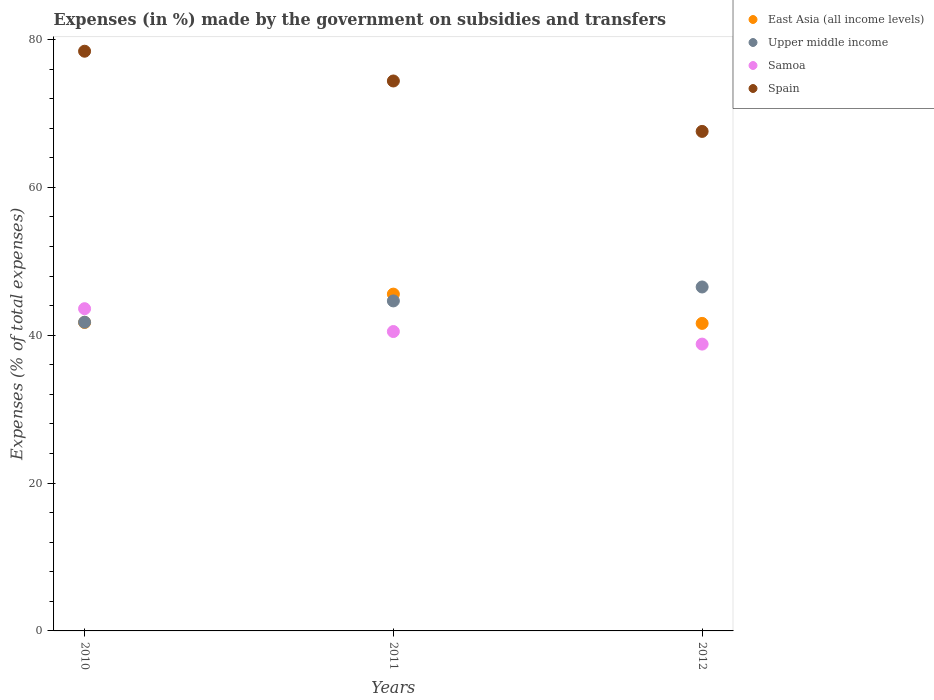How many different coloured dotlines are there?
Offer a terse response. 4. What is the percentage of expenses made by the government on subsidies and transfers in East Asia (all income levels) in 2010?
Provide a succinct answer. 41.72. Across all years, what is the maximum percentage of expenses made by the government on subsidies and transfers in Spain?
Give a very brief answer. 78.42. Across all years, what is the minimum percentage of expenses made by the government on subsidies and transfers in Samoa?
Provide a short and direct response. 38.8. What is the total percentage of expenses made by the government on subsidies and transfers in Samoa in the graph?
Your response must be concise. 122.89. What is the difference between the percentage of expenses made by the government on subsidies and transfers in Spain in 2010 and that in 2011?
Keep it short and to the point. 4.03. What is the difference between the percentage of expenses made by the government on subsidies and transfers in East Asia (all income levels) in 2011 and the percentage of expenses made by the government on subsidies and transfers in Upper middle income in 2012?
Provide a short and direct response. -0.97. What is the average percentage of expenses made by the government on subsidies and transfers in East Asia (all income levels) per year?
Your answer should be compact. 42.96. In the year 2010, what is the difference between the percentage of expenses made by the government on subsidies and transfers in Spain and percentage of expenses made by the government on subsidies and transfers in Upper middle income?
Offer a very short reply. 36.65. In how many years, is the percentage of expenses made by the government on subsidies and transfers in Samoa greater than 16 %?
Your response must be concise. 3. What is the ratio of the percentage of expenses made by the government on subsidies and transfers in Upper middle income in 2010 to that in 2011?
Ensure brevity in your answer.  0.94. Is the percentage of expenses made by the government on subsidies and transfers in Samoa in 2010 less than that in 2011?
Give a very brief answer. No. What is the difference between the highest and the second highest percentage of expenses made by the government on subsidies and transfers in Spain?
Your response must be concise. 4.03. What is the difference between the highest and the lowest percentage of expenses made by the government on subsidies and transfers in Upper middle income?
Give a very brief answer. 4.76. In how many years, is the percentage of expenses made by the government on subsidies and transfers in Samoa greater than the average percentage of expenses made by the government on subsidies and transfers in Samoa taken over all years?
Your answer should be very brief. 1. Is the sum of the percentage of expenses made by the government on subsidies and transfers in Upper middle income in 2011 and 2012 greater than the maximum percentage of expenses made by the government on subsidies and transfers in East Asia (all income levels) across all years?
Your response must be concise. Yes. Is it the case that in every year, the sum of the percentage of expenses made by the government on subsidies and transfers in Samoa and percentage of expenses made by the government on subsidies and transfers in East Asia (all income levels)  is greater than the sum of percentage of expenses made by the government on subsidies and transfers in Spain and percentage of expenses made by the government on subsidies and transfers in Upper middle income?
Ensure brevity in your answer.  No. Is it the case that in every year, the sum of the percentage of expenses made by the government on subsidies and transfers in Spain and percentage of expenses made by the government on subsidies and transfers in East Asia (all income levels)  is greater than the percentage of expenses made by the government on subsidies and transfers in Samoa?
Give a very brief answer. Yes. How many dotlines are there?
Your response must be concise. 4. What is the difference between two consecutive major ticks on the Y-axis?
Offer a very short reply. 20. Does the graph contain any zero values?
Your answer should be very brief. No. Does the graph contain grids?
Keep it short and to the point. No. Where does the legend appear in the graph?
Provide a short and direct response. Top right. What is the title of the graph?
Your answer should be compact. Expenses (in %) made by the government on subsidies and transfers. What is the label or title of the X-axis?
Your answer should be compact. Years. What is the label or title of the Y-axis?
Make the answer very short. Expenses (% of total expenses). What is the Expenses (% of total expenses) of East Asia (all income levels) in 2010?
Your response must be concise. 41.72. What is the Expenses (% of total expenses) of Upper middle income in 2010?
Your answer should be compact. 41.76. What is the Expenses (% of total expenses) in Samoa in 2010?
Provide a short and direct response. 43.59. What is the Expenses (% of total expenses) of Spain in 2010?
Give a very brief answer. 78.42. What is the Expenses (% of total expenses) in East Asia (all income levels) in 2011?
Your answer should be very brief. 45.56. What is the Expenses (% of total expenses) in Upper middle income in 2011?
Your answer should be very brief. 44.64. What is the Expenses (% of total expenses) of Samoa in 2011?
Your answer should be very brief. 40.5. What is the Expenses (% of total expenses) of Spain in 2011?
Your answer should be compact. 74.39. What is the Expenses (% of total expenses) in East Asia (all income levels) in 2012?
Make the answer very short. 41.6. What is the Expenses (% of total expenses) of Upper middle income in 2012?
Give a very brief answer. 46.53. What is the Expenses (% of total expenses) in Samoa in 2012?
Make the answer very short. 38.8. What is the Expenses (% of total expenses) of Spain in 2012?
Offer a very short reply. 67.57. Across all years, what is the maximum Expenses (% of total expenses) of East Asia (all income levels)?
Offer a terse response. 45.56. Across all years, what is the maximum Expenses (% of total expenses) of Upper middle income?
Your answer should be very brief. 46.53. Across all years, what is the maximum Expenses (% of total expenses) of Samoa?
Your answer should be compact. 43.59. Across all years, what is the maximum Expenses (% of total expenses) in Spain?
Give a very brief answer. 78.42. Across all years, what is the minimum Expenses (% of total expenses) of East Asia (all income levels)?
Offer a terse response. 41.6. Across all years, what is the minimum Expenses (% of total expenses) in Upper middle income?
Give a very brief answer. 41.76. Across all years, what is the minimum Expenses (% of total expenses) in Samoa?
Provide a short and direct response. 38.8. Across all years, what is the minimum Expenses (% of total expenses) in Spain?
Your answer should be compact. 67.57. What is the total Expenses (% of total expenses) of East Asia (all income levels) in the graph?
Offer a terse response. 128.88. What is the total Expenses (% of total expenses) in Upper middle income in the graph?
Your answer should be compact. 132.93. What is the total Expenses (% of total expenses) of Samoa in the graph?
Provide a short and direct response. 122.89. What is the total Expenses (% of total expenses) in Spain in the graph?
Your answer should be very brief. 220.38. What is the difference between the Expenses (% of total expenses) of East Asia (all income levels) in 2010 and that in 2011?
Provide a short and direct response. -3.84. What is the difference between the Expenses (% of total expenses) of Upper middle income in 2010 and that in 2011?
Ensure brevity in your answer.  -2.88. What is the difference between the Expenses (% of total expenses) in Samoa in 2010 and that in 2011?
Keep it short and to the point. 3.09. What is the difference between the Expenses (% of total expenses) of Spain in 2010 and that in 2011?
Your answer should be very brief. 4.03. What is the difference between the Expenses (% of total expenses) of East Asia (all income levels) in 2010 and that in 2012?
Offer a terse response. 0.12. What is the difference between the Expenses (% of total expenses) of Upper middle income in 2010 and that in 2012?
Provide a succinct answer. -4.76. What is the difference between the Expenses (% of total expenses) of Samoa in 2010 and that in 2012?
Ensure brevity in your answer.  4.79. What is the difference between the Expenses (% of total expenses) of Spain in 2010 and that in 2012?
Provide a short and direct response. 10.85. What is the difference between the Expenses (% of total expenses) of East Asia (all income levels) in 2011 and that in 2012?
Your response must be concise. 3.96. What is the difference between the Expenses (% of total expenses) in Upper middle income in 2011 and that in 2012?
Your answer should be compact. -1.89. What is the difference between the Expenses (% of total expenses) in Samoa in 2011 and that in 2012?
Provide a short and direct response. 1.7. What is the difference between the Expenses (% of total expenses) of Spain in 2011 and that in 2012?
Ensure brevity in your answer.  6.82. What is the difference between the Expenses (% of total expenses) of East Asia (all income levels) in 2010 and the Expenses (% of total expenses) of Upper middle income in 2011?
Your response must be concise. -2.92. What is the difference between the Expenses (% of total expenses) in East Asia (all income levels) in 2010 and the Expenses (% of total expenses) in Samoa in 2011?
Offer a terse response. 1.22. What is the difference between the Expenses (% of total expenses) in East Asia (all income levels) in 2010 and the Expenses (% of total expenses) in Spain in 2011?
Ensure brevity in your answer.  -32.67. What is the difference between the Expenses (% of total expenses) of Upper middle income in 2010 and the Expenses (% of total expenses) of Samoa in 2011?
Give a very brief answer. 1.26. What is the difference between the Expenses (% of total expenses) of Upper middle income in 2010 and the Expenses (% of total expenses) of Spain in 2011?
Provide a short and direct response. -32.63. What is the difference between the Expenses (% of total expenses) in Samoa in 2010 and the Expenses (% of total expenses) in Spain in 2011?
Your answer should be very brief. -30.8. What is the difference between the Expenses (% of total expenses) in East Asia (all income levels) in 2010 and the Expenses (% of total expenses) in Upper middle income in 2012?
Give a very brief answer. -4.81. What is the difference between the Expenses (% of total expenses) in East Asia (all income levels) in 2010 and the Expenses (% of total expenses) in Samoa in 2012?
Your answer should be very brief. 2.92. What is the difference between the Expenses (% of total expenses) in East Asia (all income levels) in 2010 and the Expenses (% of total expenses) in Spain in 2012?
Give a very brief answer. -25.85. What is the difference between the Expenses (% of total expenses) of Upper middle income in 2010 and the Expenses (% of total expenses) of Samoa in 2012?
Provide a succinct answer. 2.97. What is the difference between the Expenses (% of total expenses) of Upper middle income in 2010 and the Expenses (% of total expenses) of Spain in 2012?
Provide a short and direct response. -25.81. What is the difference between the Expenses (% of total expenses) of Samoa in 2010 and the Expenses (% of total expenses) of Spain in 2012?
Offer a very short reply. -23.98. What is the difference between the Expenses (% of total expenses) in East Asia (all income levels) in 2011 and the Expenses (% of total expenses) in Upper middle income in 2012?
Keep it short and to the point. -0.97. What is the difference between the Expenses (% of total expenses) in East Asia (all income levels) in 2011 and the Expenses (% of total expenses) in Samoa in 2012?
Provide a succinct answer. 6.76. What is the difference between the Expenses (% of total expenses) in East Asia (all income levels) in 2011 and the Expenses (% of total expenses) in Spain in 2012?
Offer a terse response. -22.01. What is the difference between the Expenses (% of total expenses) in Upper middle income in 2011 and the Expenses (% of total expenses) in Samoa in 2012?
Ensure brevity in your answer.  5.84. What is the difference between the Expenses (% of total expenses) in Upper middle income in 2011 and the Expenses (% of total expenses) in Spain in 2012?
Offer a terse response. -22.93. What is the difference between the Expenses (% of total expenses) in Samoa in 2011 and the Expenses (% of total expenses) in Spain in 2012?
Your answer should be very brief. -27.07. What is the average Expenses (% of total expenses) in East Asia (all income levels) per year?
Provide a succinct answer. 42.96. What is the average Expenses (% of total expenses) in Upper middle income per year?
Offer a terse response. 44.31. What is the average Expenses (% of total expenses) in Samoa per year?
Your response must be concise. 40.96. What is the average Expenses (% of total expenses) in Spain per year?
Provide a succinct answer. 73.46. In the year 2010, what is the difference between the Expenses (% of total expenses) in East Asia (all income levels) and Expenses (% of total expenses) in Upper middle income?
Offer a terse response. -0.04. In the year 2010, what is the difference between the Expenses (% of total expenses) of East Asia (all income levels) and Expenses (% of total expenses) of Samoa?
Give a very brief answer. -1.87. In the year 2010, what is the difference between the Expenses (% of total expenses) of East Asia (all income levels) and Expenses (% of total expenses) of Spain?
Provide a short and direct response. -36.7. In the year 2010, what is the difference between the Expenses (% of total expenses) in Upper middle income and Expenses (% of total expenses) in Samoa?
Offer a terse response. -1.82. In the year 2010, what is the difference between the Expenses (% of total expenses) in Upper middle income and Expenses (% of total expenses) in Spain?
Offer a terse response. -36.65. In the year 2010, what is the difference between the Expenses (% of total expenses) of Samoa and Expenses (% of total expenses) of Spain?
Provide a short and direct response. -34.83. In the year 2011, what is the difference between the Expenses (% of total expenses) of East Asia (all income levels) and Expenses (% of total expenses) of Upper middle income?
Your response must be concise. 0.92. In the year 2011, what is the difference between the Expenses (% of total expenses) in East Asia (all income levels) and Expenses (% of total expenses) in Samoa?
Offer a terse response. 5.06. In the year 2011, what is the difference between the Expenses (% of total expenses) in East Asia (all income levels) and Expenses (% of total expenses) in Spain?
Your response must be concise. -28.83. In the year 2011, what is the difference between the Expenses (% of total expenses) of Upper middle income and Expenses (% of total expenses) of Samoa?
Provide a short and direct response. 4.14. In the year 2011, what is the difference between the Expenses (% of total expenses) in Upper middle income and Expenses (% of total expenses) in Spain?
Keep it short and to the point. -29.75. In the year 2011, what is the difference between the Expenses (% of total expenses) of Samoa and Expenses (% of total expenses) of Spain?
Provide a short and direct response. -33.89. In the year 2012, what is the difference between the Expenses (% of total expenses) in East Asia (all income levels) and Expenses (% of total expenses) in Upper middle income?
Your answer should be compact. -4.93. In the year 2012, what is the difference between the Expenses (% of total expenses) of East Asia (all income levels) and Expenses (% of total expenses) of Samoa?
Ensure brevity in your answer.  2.8. In the year 2012, what is the difference between the Expenses (% of total expenses) in East Asia (all income levels) and Expenses (% of total expenses) in Spain?
Ensure brevity in your answer.  -25.97. In the year 2012, what is the difference between the Expenses (% of total expenses) of Upper middle income and Expenses (% of total expenses) of Samoa?
Ensure brevity in your answer.  7.73. In the year 2012, what is the difference between the Expenses (% of total expenses) in Upper middle income and Expenses (% of total expenses) in Spain?
Offer a terse response. -21.04. In the year 2012, what is the difference between the Expenses (% of total expenses) in Samoa and Expenses (% of total expenses) in Spain?
Your answer should be compact. -28.77. What is the ratio of the Expenses (% of total expenses) of East Asia (all income levels) in 2010 to that in 2011?
Your response must be concise. 0.92. What is the ratio of the Expenses (% of total expenses) in Upper middle income in 2010 to that in 2011?
Your answer should be very brief. 0.94. What is the ratio of the Expenses (% of total expenses) of Samoa in 2010 to that in 2011?
Your response must be concise. 1.08. What is the ratio of the Expenses (% of total expenses) of Spain in 2010 to that in 2011?
Ensure brevity in your answer.  1.05. What is the ratio of the Expenses (% of total expenses) of East Asia (all income levels) in 2010 to that in 2012?
Your answer should be compact. 1. What is the ratio of the Expenses (% of total expenses) in Upper middle income in 2010 to that in 2012?
Offer a terse response. 0.9. What is the ratio of the Expenses (% of total expenses) in Samoa in 2010 to that in 2012?
Offer a terse response. 1.12. What is the ratio of the Expenses (% of total expenses) of Spain in 2010 to that in 2012?
Give a very brief answer. 1.16. What is the ratio of the Expenses (% of total expenses) in East Asia (all income levels) in 2011 to that in 2012?
Give a very brief answer. 1.1. What is the ratio of the Expenses (% of total expenses) of Upper middle income in 2011 to that in 2012?
Provide a short and direct response. 0.96. What is the ratio of the Expenses (% of total expenses) in Samoa in 2011 to that in 2012?
Your answer should be very brief. 1.04. What is the ratio of the Expenses (% of total expenses) of Spain in 2011 to that in 2012?
Ensure brevity in your answer.  1.1. What is the difference between the highest and the second highest Expenses (% of total expenses) of East Asia (all income levels)?
Provide a short and direct response. 3.84. What is the difference between the highest and the second highest Expenses (% of total expenses) in Upper middle income?
Ensure brevity in your answer.  1.89. What is the difference between the highest and the second highest Expenses (% of total expenses) of Samoa?
Offer a very short reply. 3.09. What is the difference between the highest and the second highest Expenses (% of total expenses) in Spain?
Your response must be concise. 4.03. What is the difference between the highest and the lowest Expenses (% of total expenses) of East Asia (all income levels)?
Ensure brevity in your answer.  3.96. What is the difference between the highest and the lowest Expenses (% of total expenses) of Upper middle income?
Your response must be concise. 4.76. What is the difference between the highest and the lowest Expenses (% of total expenses) in Samoa?
Keep it short and to the point. 4.79. What is the difference between the highest and the lowest Expenses (% of total expenses) in Spain?
Keep it short and to the point. 10.85. 